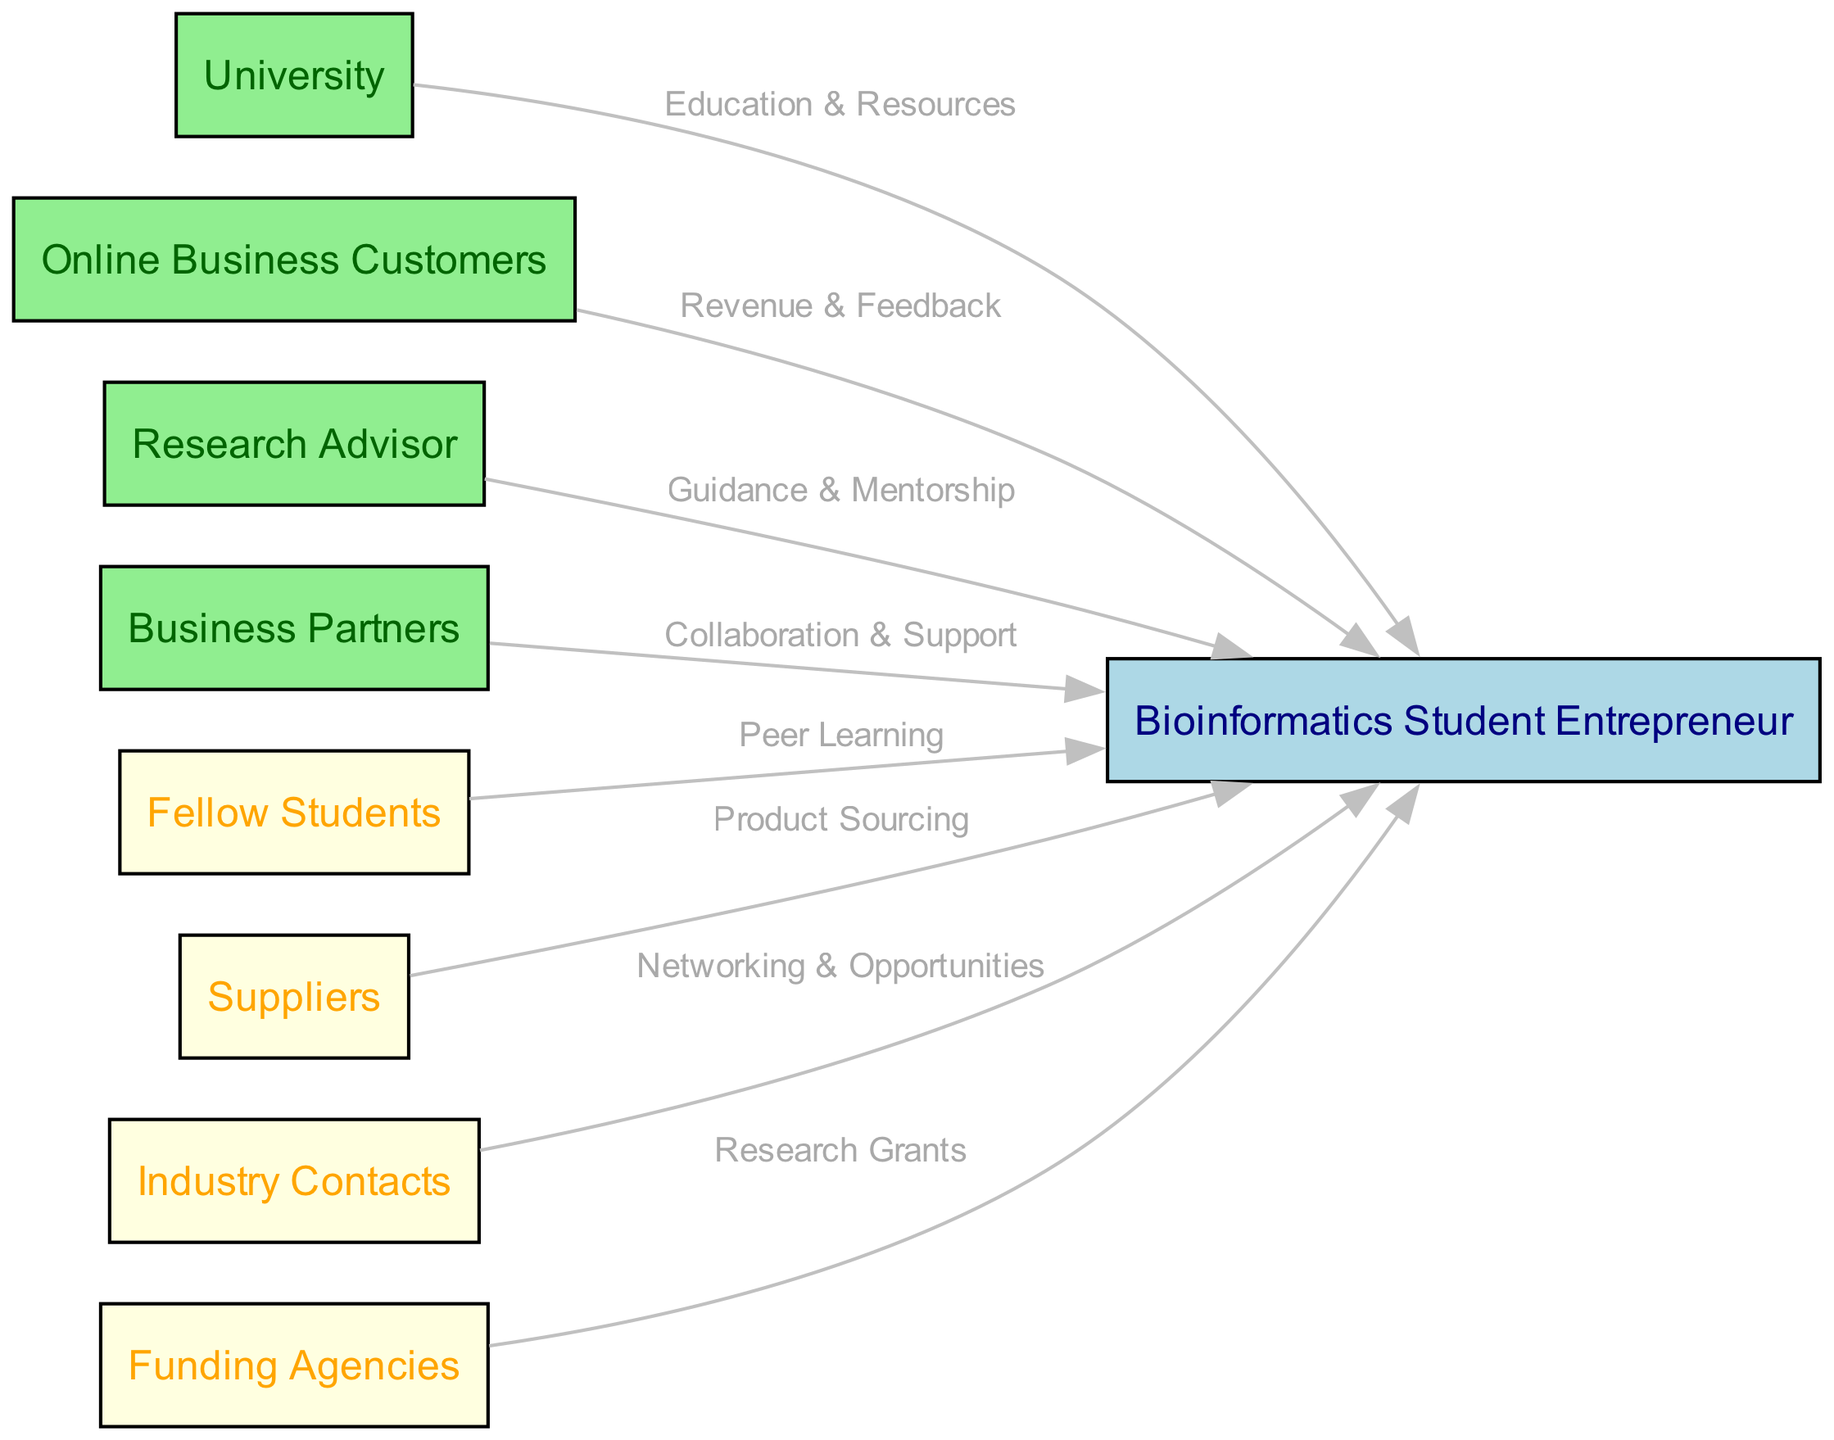What is the central node of the diagram? The central node is labeled "Bioinformatics Student Entrepreneur," which is directly provided in the data as the central focus of the stakeholder analysis.
Answer: Bioinformatics Student Entrepreneur How many primary stakeholders are there? The diagram contains four primary stakeholders listed under "primaryStakeholders," including University, Online Business Customers, Research Advisor, and Business Partners. The count can be quickly verified by counting the entries.
Answer: 4 What is the relationship label between the Research Advisor and the Bioinformatics Student Entrepreneur? The relationship from the Research Advisor to the Bioinformatics Student Entrepreneur is labeled "Guidance & Mentorship," as indicated in the relationships section of the data.
Answer: Guidance & Mentorship Which stakeholder is associated with product sourcing? The stakeholder associated with product sourcing is Suppliers, which is included in the secondary stakeholders and connected to the central node with that specific relationship label.
Answer: Suppliers What type of feedback does the Bioinformatics Student Entrepreneur receive from Online Business Customers? The feedback from Online Business Customers is labeled as "Revenue & Feedback," which clarifies the nature of the relationship in the diagram.
Answer: Revenue & Feedback How many secondary stakeholders are listed? The diagram lists four secondary stakeholders under "secondaryStakeholders," including Fellow Students, Suppliers, Industry Contacts, and Funding Agencies. A count of these entries reveals the total.
Answer: 4 What type of collaboration does the Business Partners provide? The collaboration provided by Business Partners is labeled "Collaboration & Support," which explicitly states the nature of the relationship in the diagram.
Answer: Collaboration & Support What is the purpose of the connection between Industry Contacts and the Bioinformatics Student Entrepreneur? The connection between Industry Contacts and the Bioinformatics Student Entrepreneur is labeled "Networking & Opportunities," indicating the purpose of this relationship.
Answer: Networking & Opportunities Which stakeholder is responsible for providing research grants? The stakeholder responsible for providing research grants is Funding Agencies, as stated in the relationships section of the diagram.
Answer: Funding Agencies 